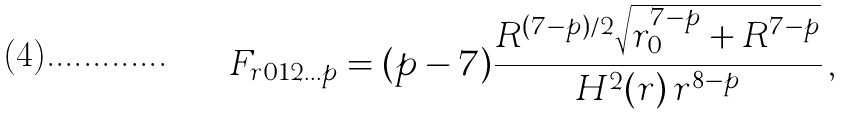Convert formula to latex. <formula><loc_0><loc_0><loc_500><loc_500>F _ { r 0 1 2 \dots p } = ( p - 7 ) \frac { R ^ { ( 7 - p ) / 2 } \sqrt { r _ { 0 } ^ { 7 - p } + R ^ { 7 - p } } } { H ^ { 2 } ( r ) \, r ^ { 8 - p } } \, ,</formula> 